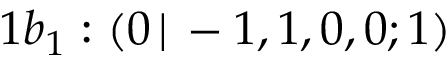Convert formula to latex. <formula><loc_0><loc_0><loc_500><loc_500>1 b _ { 1 } \colon ( 0 \, | \, - 1 , 1 , 0 , 0 ; 1 )</formula> 